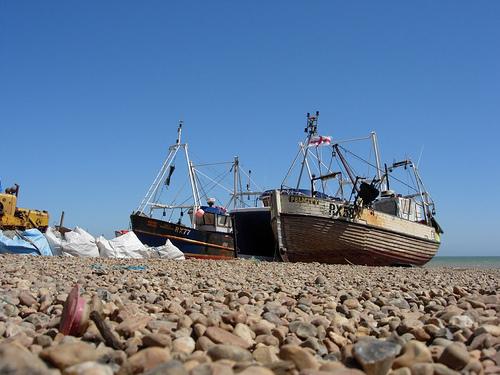Is the boat on water?
Short answer required. No. Is there any people available here?
Short answer required. No. Is it day or night?
Concise answer only. Day. What is the weather like?
Write a very short answer. Clear. 